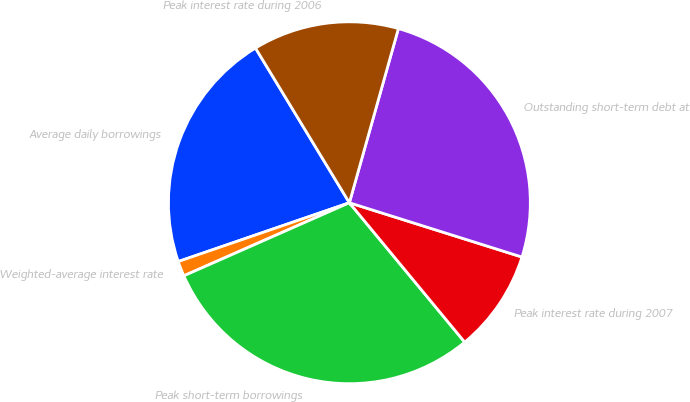Convert chart to OTSL. <chart><loc_0><loc_0><loc_500><loc_500><pie_chart><fcel>Average daily borrowings<fcel>Weighted-average interest rate<fcel>Peak short-term borrowings<fcel>Peak interest rate during 2007<fcel>Outstanding short-term debt at<fcel>Peak interest rate during 2006<nl><fcel>21.59%<fcel>1.35%<fcel>29.39%<fcel>9.15%<fcel>25.49%<fcel>13.05%<nl></chart> 